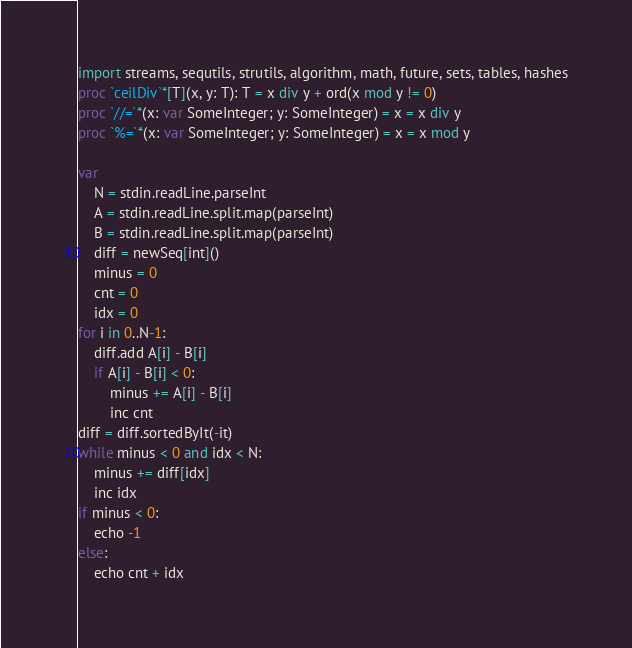<code> <loc_0><loc_0><loc_500><loc_500><_Nim_>import streams, sequtils, strutils, algorithm, math, future, sets, tables, hashes
proc `ceilDiv`*[T](x, y: T): T = x div y + ord(x mod y != 0)
proc `//=`*(x: var SomeInteger; y: SomeInteger) = x = x div y
proc `%=`*(x: var SomeInteger; y: SomeInteger) = x = x mod y

var
    N = stdin.readLine.parseInt
    A = stdin.readLine.split.map(parseInt)
    B = stdin.readLine.split.map(parseInt)
    diff = newSeq[int]()
    minus = 0
    cnt = 0
    idx = 0
for i in 0..N-1:
    diff.add A[i] - B[i]
    if A[i] - B[i] < 0:
        minus += A[i] - B[i]
        inc cnt
diff = diff.sortedByIt(-it)
while minus < 0 and idx < N:
    minus += diff[idx]
    inc idx
if minus < 0:
    echo -1
else:
    echo cnt + idx



</code> 